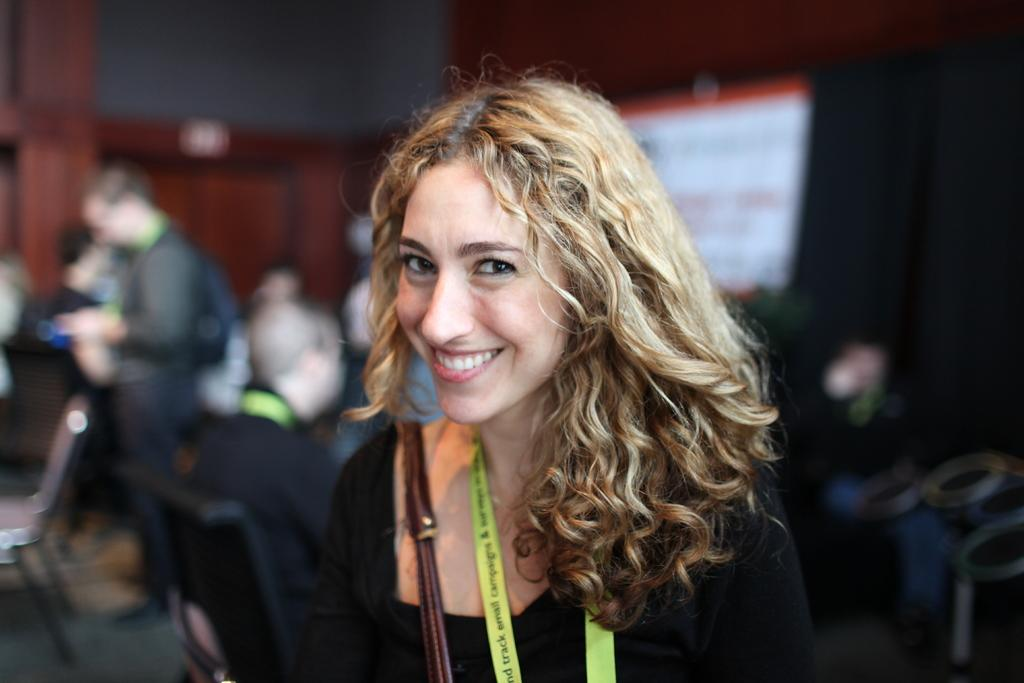Who is present in the image? There is a woman in the image. What is the woman doing in the image? The woman is smiling in the image. Can you describe the other people in the image? There is a group of people in the image. What can be observed about the background of the image? The background of the image is blurred. What type of fowl can be seen in the image? There is no fowl present in the image. How many sinks are visible in the image? There are no sinks visible in the image. 